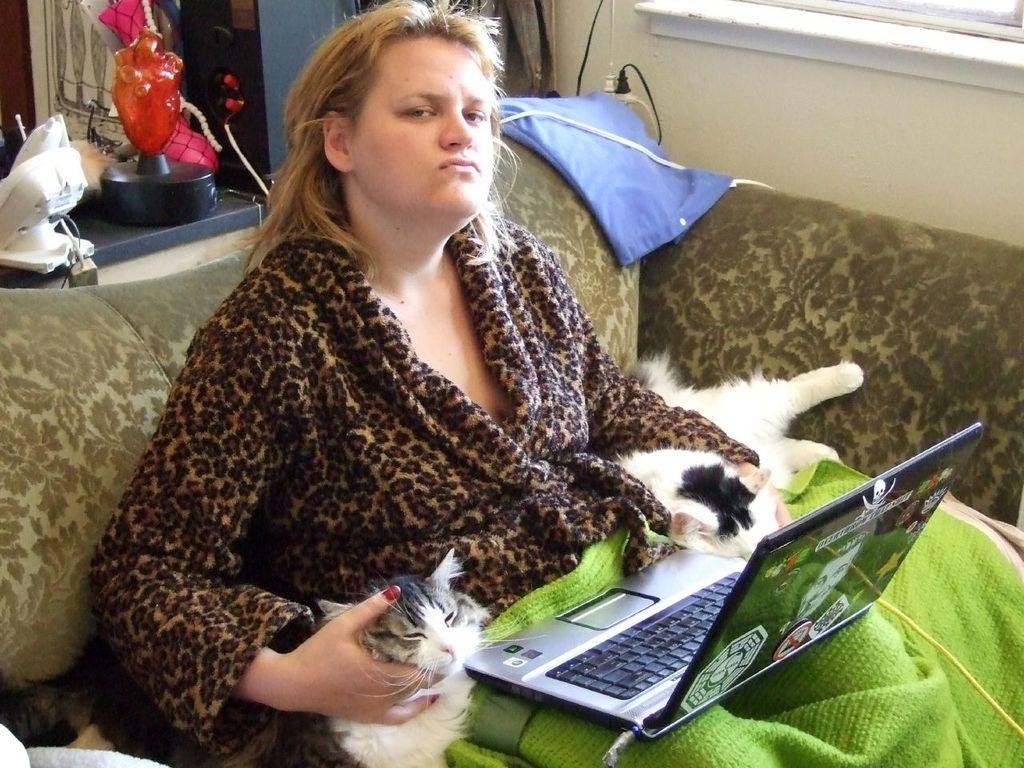Who is the main subject in the picture? There is a woman in the picture. What is the woman doing in the image? The woman is sitting on a chair and working on a laptop. Is there any other object or living being in the woman's hands? Yes, there is a cat in the woman's hands. What type of nut can be seen in the woman's pocket in the image? There is no nut visible in the woman's pocket in the image. Is there a cave in the background of the image? There is no cave present in the image. 